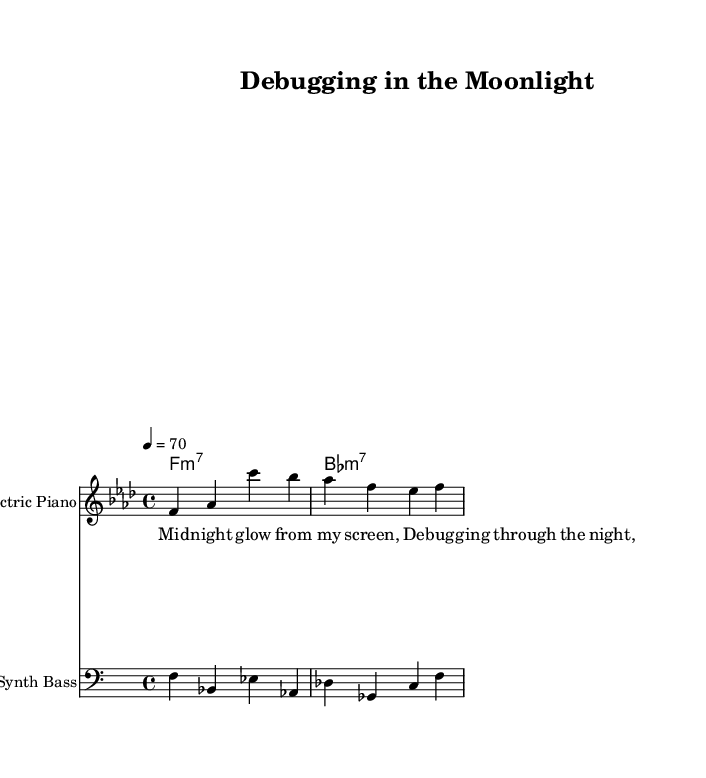What is the key signature of this music? The key signature shows that there are four flats, indicating it is in F minor.
Answer: F minor What is the time signature of this piece? The time signature is displayed at the beginning of the score as 4/4, which indicates four beats per measure.
Answer: 4/4 What tempo is indicated for this music? The tempo marking indicates a speed of 70 beats per minute, denoted by the quarter note equaling 70.
Answer: 70 What instrument is primarily used for the melody? The instrument name at the beginning of the melody staff is "Electric Piano", which plays the main melodic lines.
Answer: Electric Piano How many measures are in the melody? By counting the measures in the melody section, there are a total of three measures present.
Answer: 3 What type of chords are used in the harmonies? The harmonies indicate a progression of two minor seventh chords: F minor 7 and B flat minor 7.
Answer: Minor seventh chords What are the main themes expressed in the lyrics? The lyrics introduced reflect a theme of late-night debugging, capturing the mood of a solitary programmer working late.
Answer: Late-night debugging 